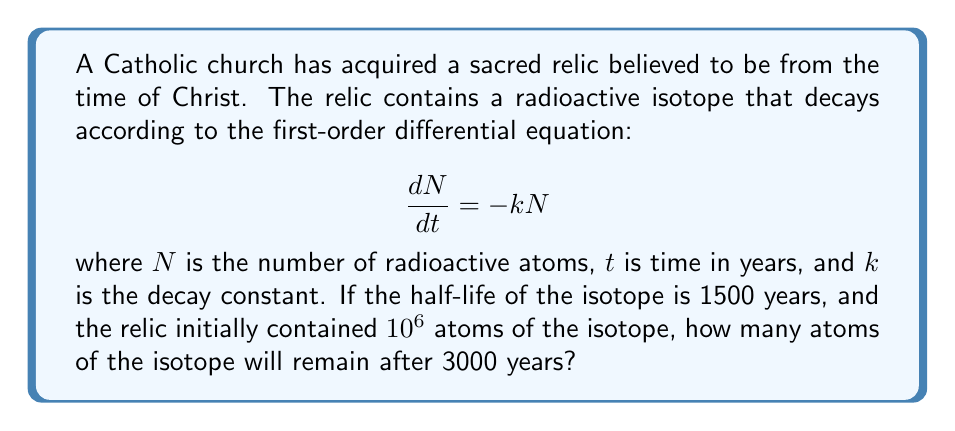Can you answer this question? To solve this problem, we'll follow these steps:

1) First, we need to find the decay constant $k$ using the half-life information.
   The half-life formula is: $t_{1/2} = \frac{\ln(2)}{k}$
   
   Rearranging this, we get: $k = \frac{\ln(2)}{t_{1/2}} = \frac{\ln(2)}{1500} \approx 0.000462$ per year

2) Now we can use the solution to the first-order differential equation for radioactive decay:
   $N(t) = N_0e^{-kt}$
   
   Where $N_0$ is the initial number of atoms and $t$ is the time in years.

3) We're given:
   $N_0 = 10^6$ atoms
   $t = 3000$ years
   $k \approx 0.000462$ per year

4) Plugging these values into our equation:
   $N(3000) = 10^6 \cdot e^{-0.000462 \cdot 3000}$

5) Calculating this:
   $N(3000) = 10^6 \cdot e^{-1.386} \approx 250,000$ atoms

Therefore, after 3000 years, approximately 250,000 atoms of the radioactive isotope will remain in the relic.
Answer: Approximately 250,000 atoms 